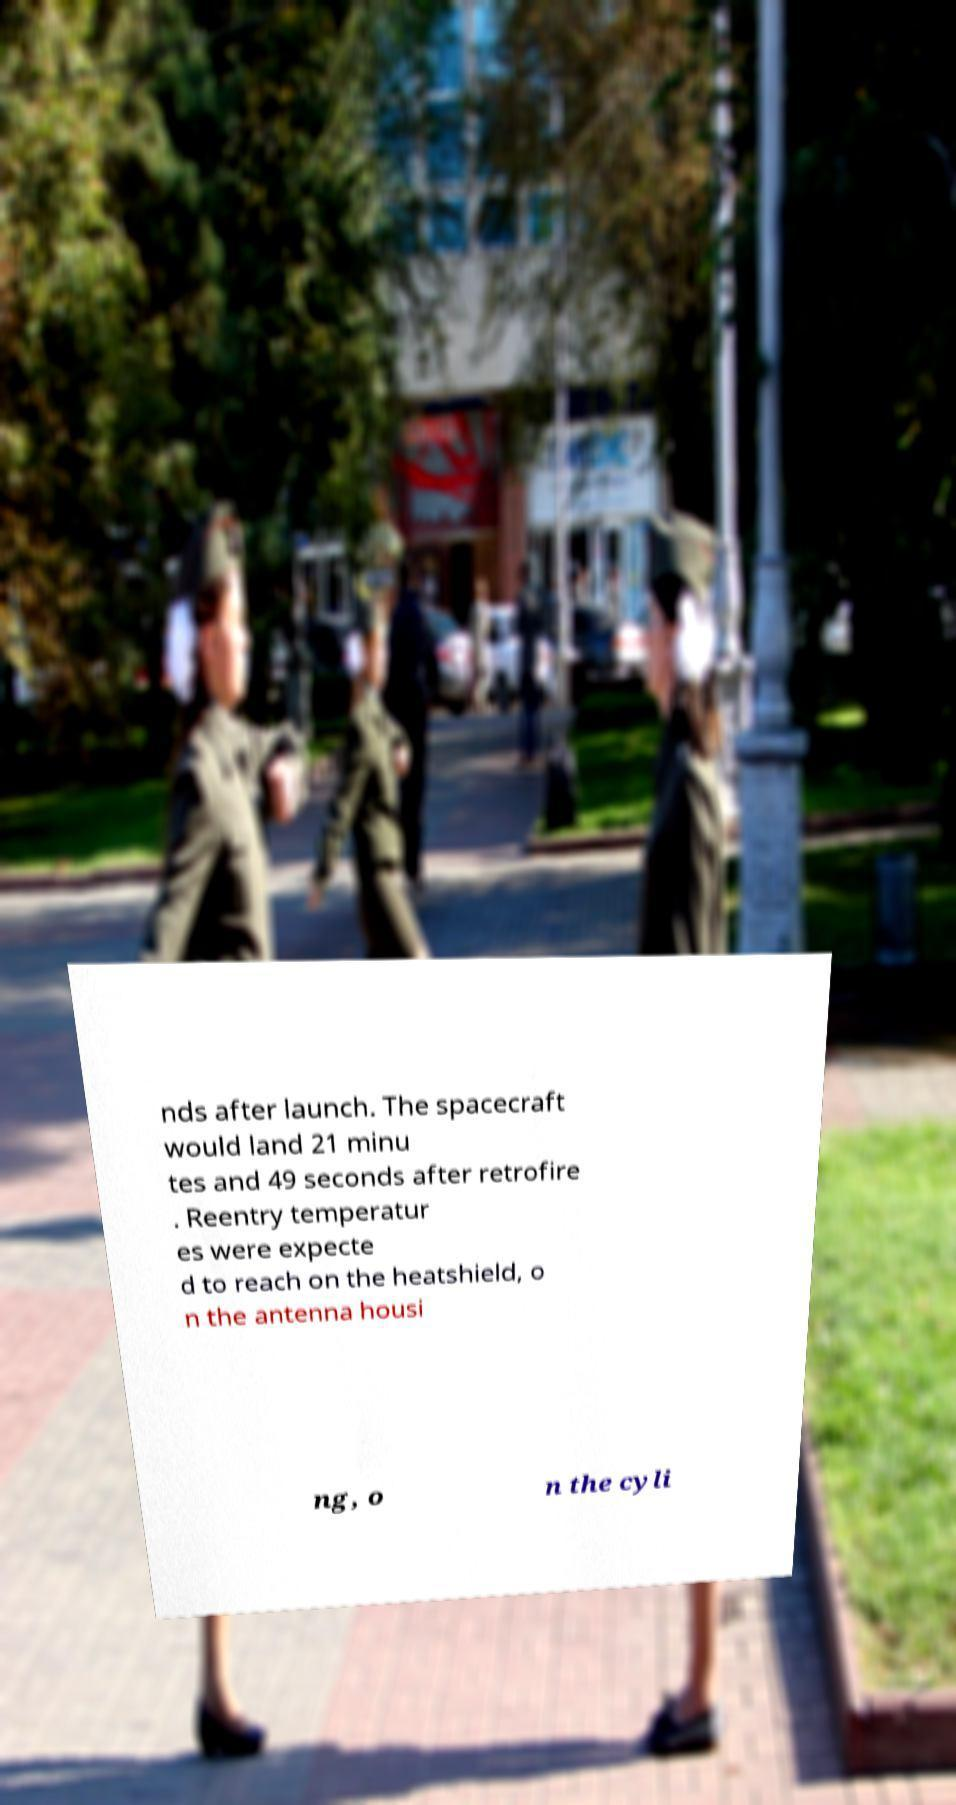For documentation purposes, I need the text within this image transcribed. Could you provide that? nds after launch. The spacecraft would land 21 minu tes and 49 seconds after retrofire . Reentry temperatur es were expecte d to reach on the heatshield, o n the antenna housi ng, o n the cyli 